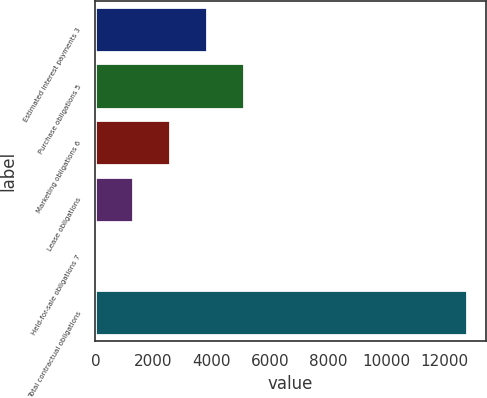<chart> <loc_0><loc_0><loc_500><loc_500><bar_chart><fcel>Estimated interest payments 3<fcel>Purchase obligations 5<fcel>Marketing obligations 6<fcel>Lease obligations<fcel>Held-for-sale obligations 7<fcel>Total contractual obligations<nl><fcel>3843<fcel>5121<fcel>2565<fcel>1287<fcel>9<fcel>12789<nl></chart> 